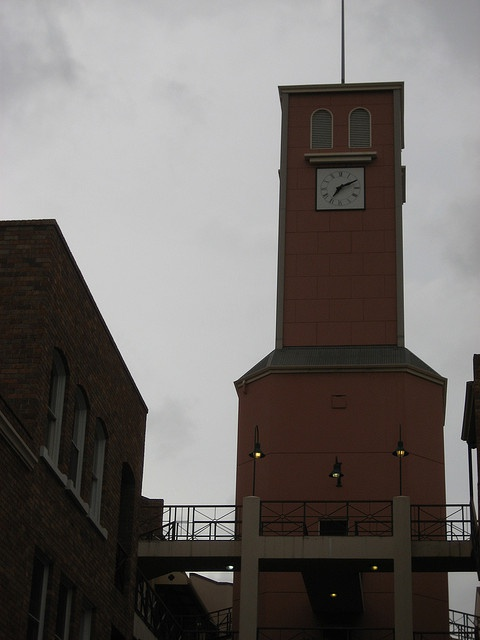Describe the objects in this image and their specific colors. I can see a clock in darkgray, gray, and black tones in this image. 